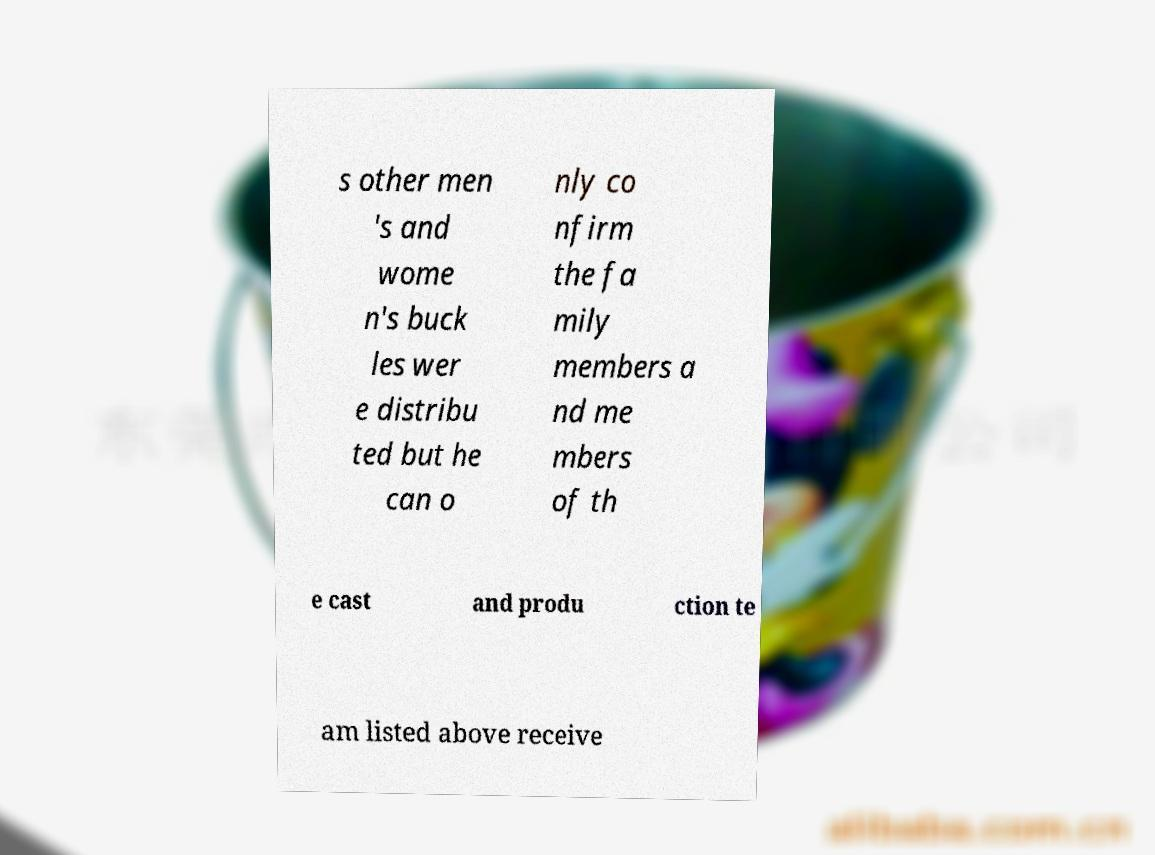Could you assist in decoding the text presented in this image and type it out clearly? s other men 's and wome n's buck les wer e distribu ted but he can o nly co nfirm the fa mily members a nd me mbers of th e cast and produ ction te am listed above receive 